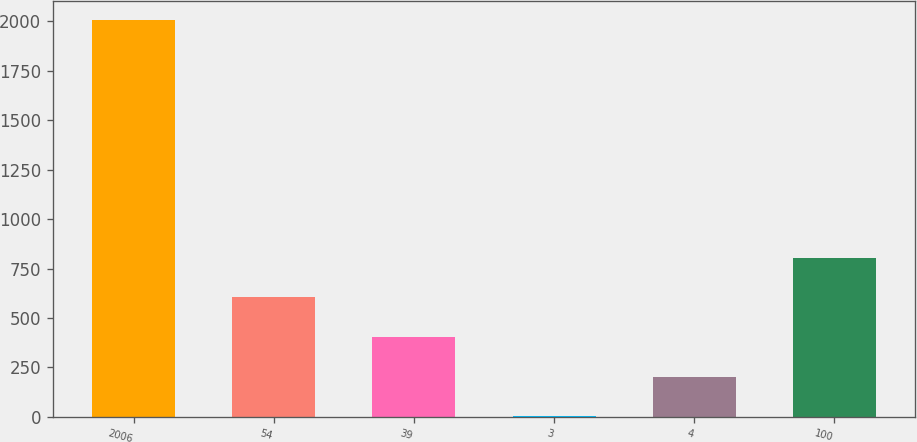Convert chart. <chart><loc_0><loc_0><loc_500><loc_500><bar_chart><fcel>2006<fcel>54<fcel>39<fcel>3<fcel>4<fcel>100<nl><fcel>2005<fcel>603.6<fcel>403.4<fcel>3<fcel>203.2<fcel>803.8<nl></chart> 